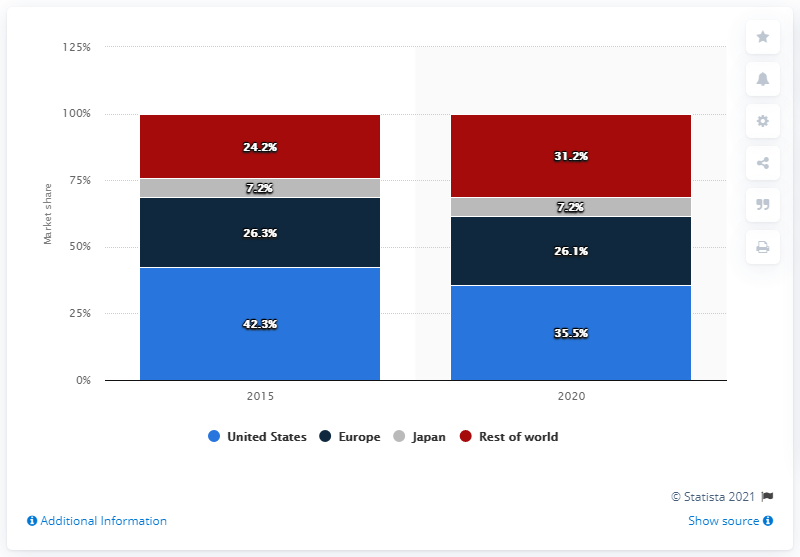Identify some key points in this picture. The global vascular closure devices market is forecasted to reach a certain year in the future, specifically in 2020. The vascular closure devices market began to grow globally in the year 2015. 